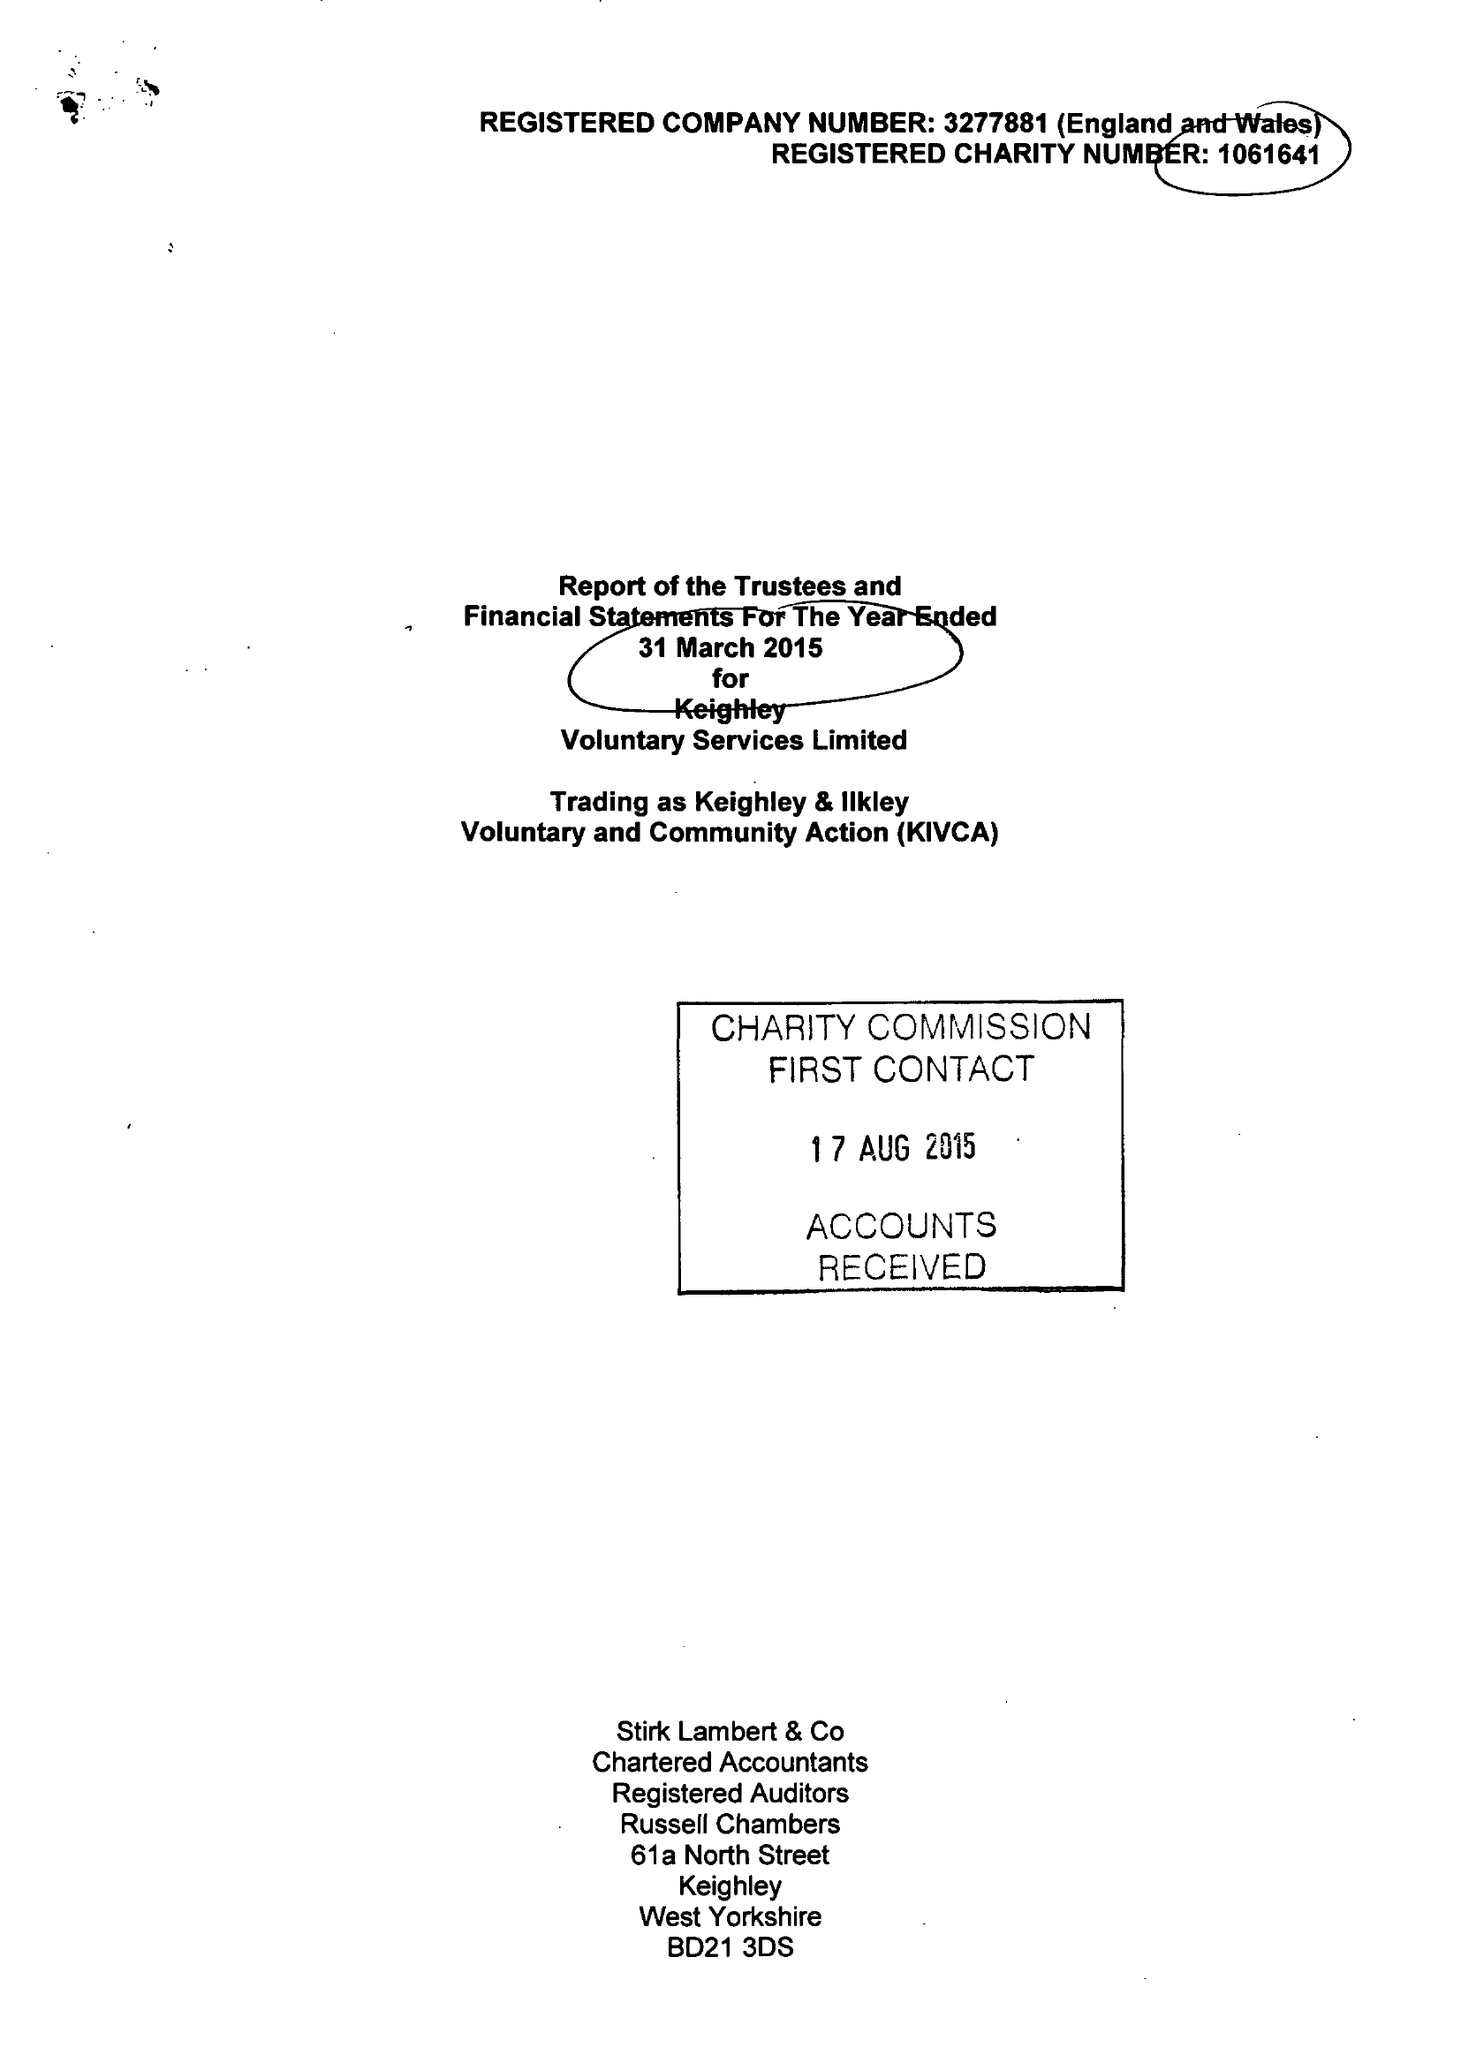What is the value for the address__postcode?
Answer the question using a single word or phrase. BD21 3JD 